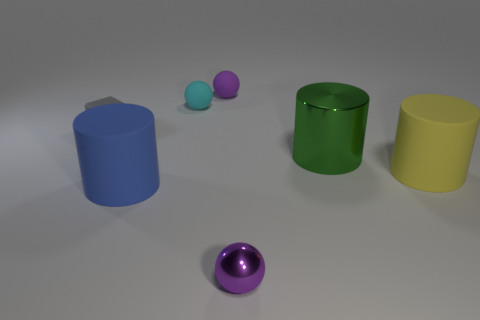There is a large shiny object; does it have the same shape as the object right of the large metallic thing?
Provide a short and direct response. Yes. What number of things are either things on the left side of the blue thing or green cylinders?
Provide a short and direct response. 2. Are there any other things that have the same material as the gray object?
Make the answer very short. Yes. How many tiny balls are both in front of the green cylinder and behind the tiny cube?
Provide a short and direct response. 0. What number of objects are either large things left of the small purple matte thing or matte objects that are behind the blue rubber cylinder?
Make the answer very short. 5. What number of other things are the same shape as the tiny shiny thing?
Offer a very short reply. 2. Do the big rubber cylinder to the left of the small metal object and the metal sphere have the same color?
Provide a succinct answer. No. What number of other objects are the same size as the yellow object?
Make the answer very short. 2. Do the gray object and the big green cylinder have the same material?
Provide a succinct answer. No. There is a rubber cylinder that is to the left of the small purple object that is in front of the gray matte cube; what color is it?
Offer a very short reply. Blue. 